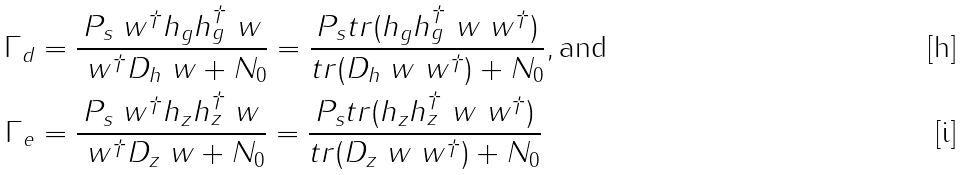<formula> <loc_0><loc_0><loc_500><loc_500>\Gamma _ { d } & = \frac { P _ { s } \ w ^ { \dagger } h _ { g } h _ { g } ^ { \dagger } \ w } { \ w ^ { \dagger } D _ { h } \ w + N _ { 0 } } = \frac { P _ { s } t r ( h _ { g } h _ { g } ^ { \dagger } \ w \ w ^ { \dagger } ) } { t r ( D _ { h } \ w \ w ^ { \dagger } ) + N _ { 0 } } , \text {and} \\ \Gamma _ { e } & = \frac { P _ { s } \ w ^ { \dagger } h _ { z } h _ { z } ^ { \dagger } \ w } { \ w ^ { \dagger } D _ { z } \ w + N _ { 0 } } = \frac { P _ { s } t r ( h _ { z } h _ { z } ^ { \dagger } \ w \ w ^ { \dagger } ) } { t r ( D _ { z } \ w \ w ^ { \dagger } ) + N _ { 0 } }</formula> 